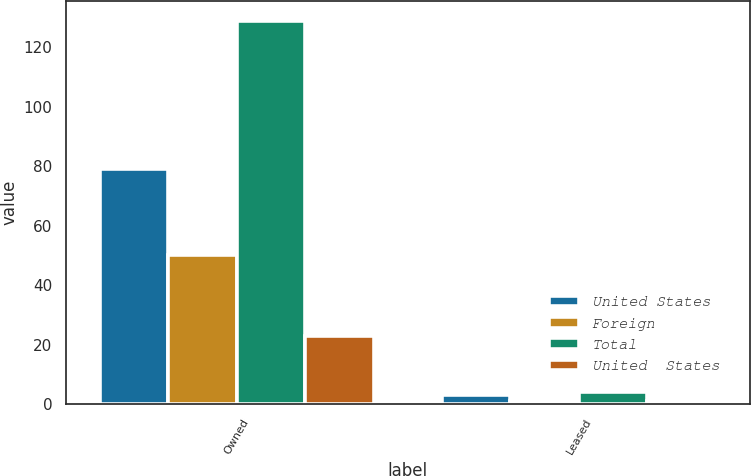<chart> <loc_0><loc_0><loc_500><loc_500><stacked_bar_chart><ecel><fcel>Owned<fcel>Leased<nl><fcel>United States<fcel>79<fcel>3<nl><fcel>Foreign<fcel>50<fcel>1<nl><fcel>Total<fcel>129<fcel>4<nl><fcel>United  States<fcel>23<fcel>1<nl></chart> 